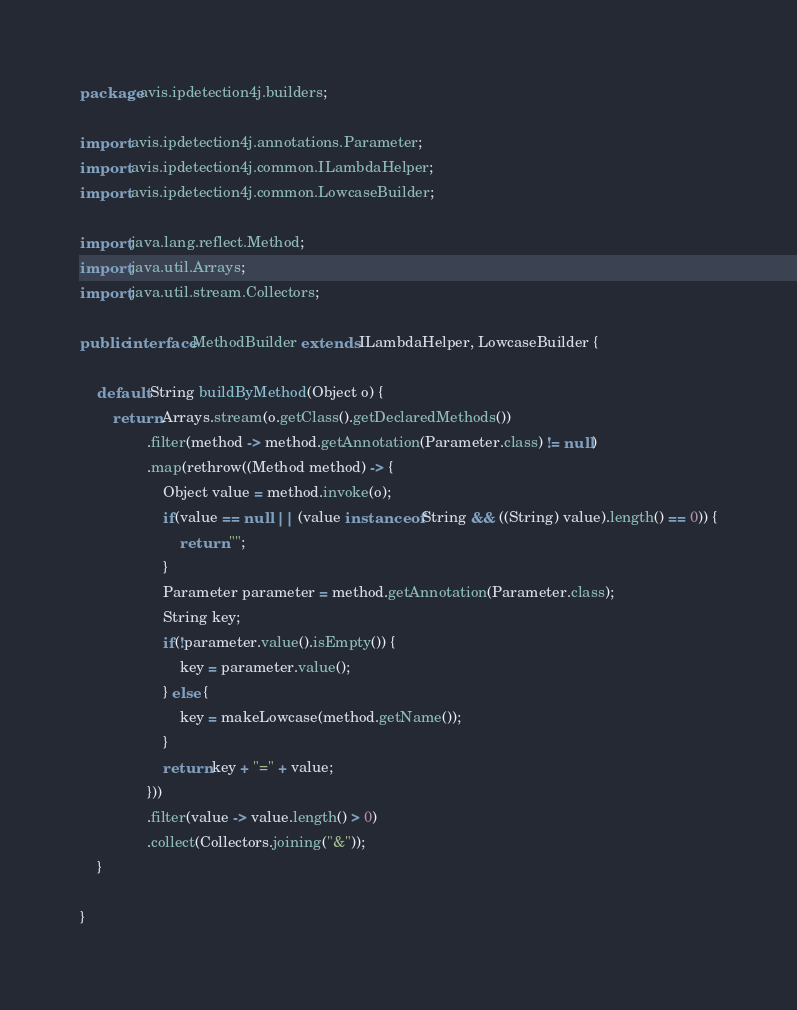<code> <loc_0><loc_0><loc_500><loc_500><_Java_>package avis.ipdetection4j.builders;

import avis.ipdetection4j.annotations.Parameter;
import avis.ipdetection4j.common.ILambdaHelper;
import avis.ipdetection4j.common.LowcaseBuilder;

import java.lang.reflect.Method;
import java.util.Arrays;
import java.util.stream.Collectors;

public interface MethodBuilder extends ILambdaHelper, LowcaseBuilder {

    default String buildByMethod(Object o) {
        return Arrays.stream(o.getClass().getDeclaredMethods())
                .filter(method -> method.getAnnotation(Parameter.class) != null)
                .map(rethrow((Method method) -> {
                    Object value = method.invoke(o);
                    if(value == null || (value instanceof String && ((String) value).length() == 0)) {
                        return "";
                    }
                    Parameter parameter = method.getAnnotation(Parameter.class);
                    String key;
                    if(!parameter.value().isEmpty()) {
                        key = parameter.value();
                    } else {
                        key = makeLowcase(method.getName());
                    }
                    return key + "=" + value;
                }))
                .filter(value -> value.length() > 0)
                .collect(Collectors.joining("&"));
    }

}
</code> 